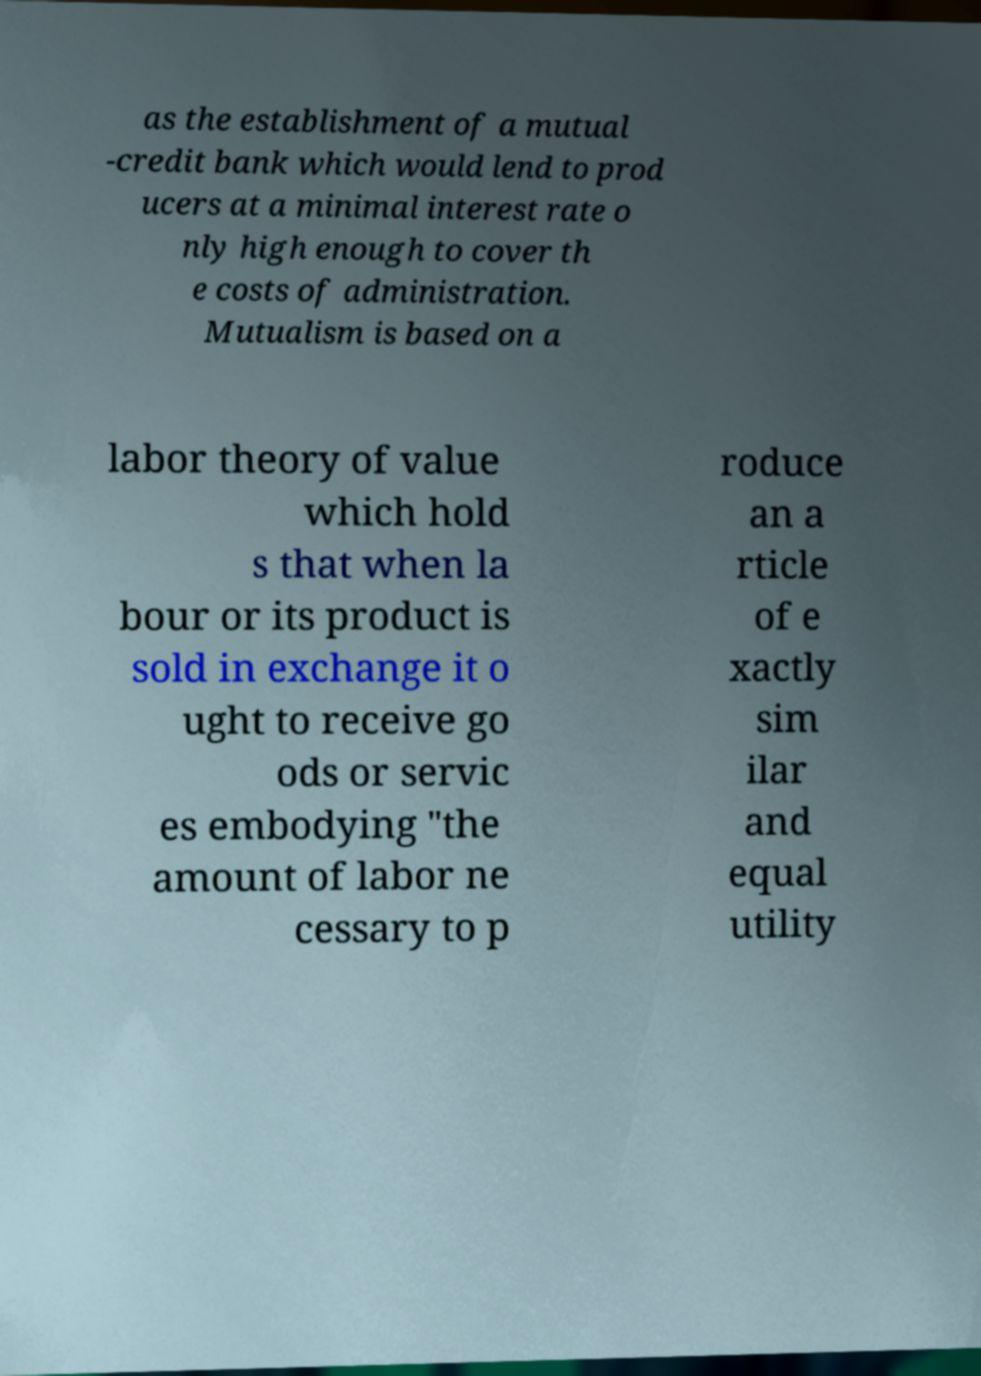I need the written content from this picture converted into text. Can you do that? as the establishment of a mutual -credit bank which would lend to prod ucers at a minimal interest rate o nly high enough to cover th e costs of administration. Mutualism is based on a labor theory of value which hold s that when la bour or its product is sold in exchange it o ught to receive go ods or servic es embodying "the amount of labor ne cessary to p roduce an a rticle of e xactly sim ilar and equal utility 